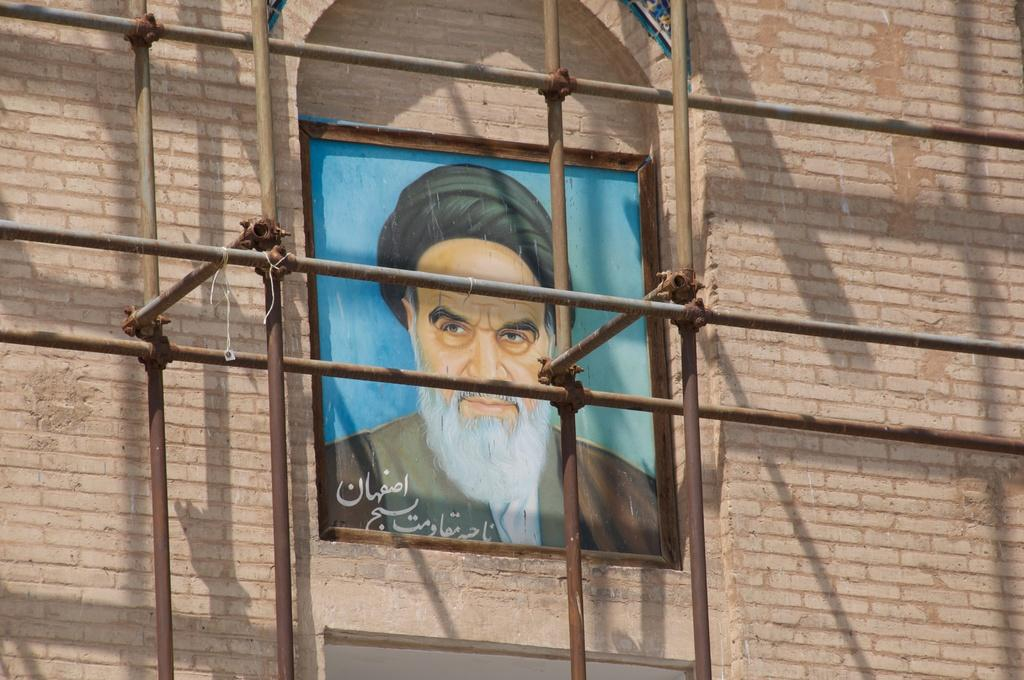What is present on the wall in the image? There is an image of a person on the wall. What else can be seen in the image besides the wall? There are many poles in front of the wall. What type of print is visible on the goat in the image? There is no goat present in the image, so it is not possible to determine what type of print might be visible on it. 